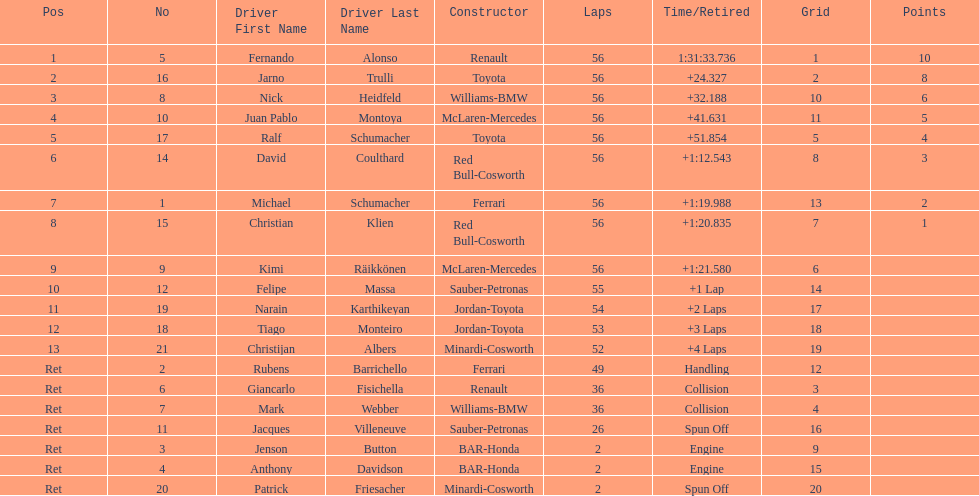What driver finished first? Fernando Alonso. 